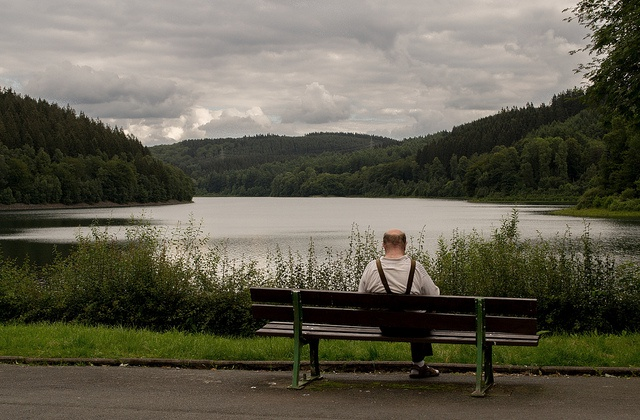Describe the objects in this image and their specific colors. I can see bench in darkgray, black, gray, and darkgreen tones and people in darkgray, black, and gray tones in this image. 